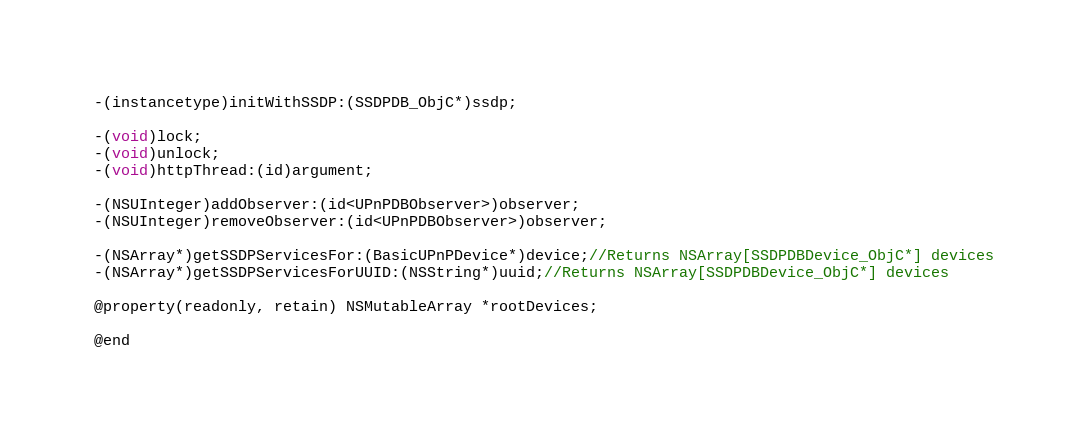Convert code to text. <code><loc_0><loc_0><loc_500><loc_500><_C_>-(instancetype)initWithSSDP:(SSDPDB_ObjC*)ssdp;

-(void)lock;
-(void)unlock;
-(void)httpThread:(id)argument;

-(NSUInteger)addObserver:(id<UPnPDBObserver>)observer;
-(NSUInteger)removeObserver:(id<UPnPDBObserver>)observer;

-(NSArray*)getSSDPServicesFor:(BasicUPnPDevice*)device;//Returns NSArray[SSDPDBDevice_ObjC*] devices
-(NSArray*)getSSDPServicesForUUID:(NSString*)uuid;//Returns NSArray[SSDPDBDevice_ObjC*] devices

@property(readonly, retain) NSMutableArray *rootDevices;

@end
</code> 